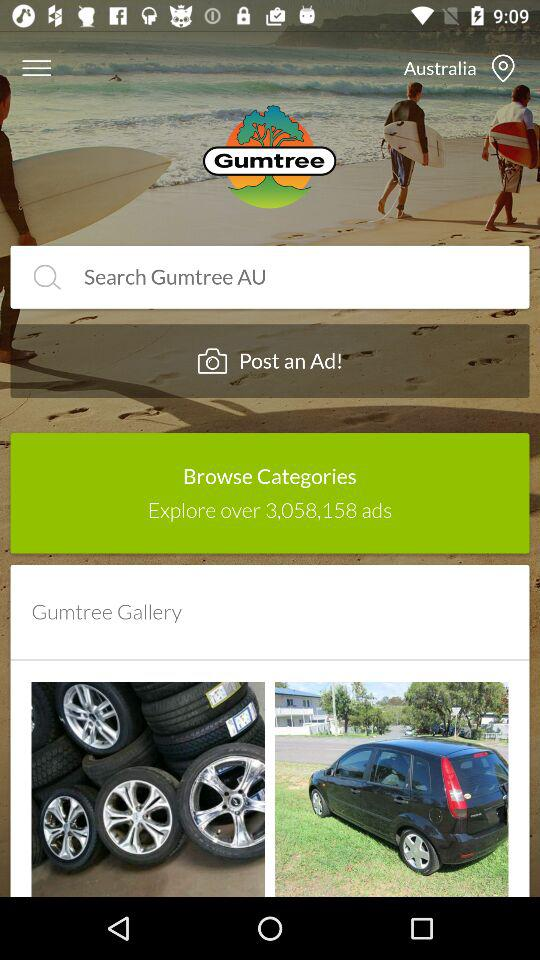What is the location given on the screen? The location given on the screen is Australia. 